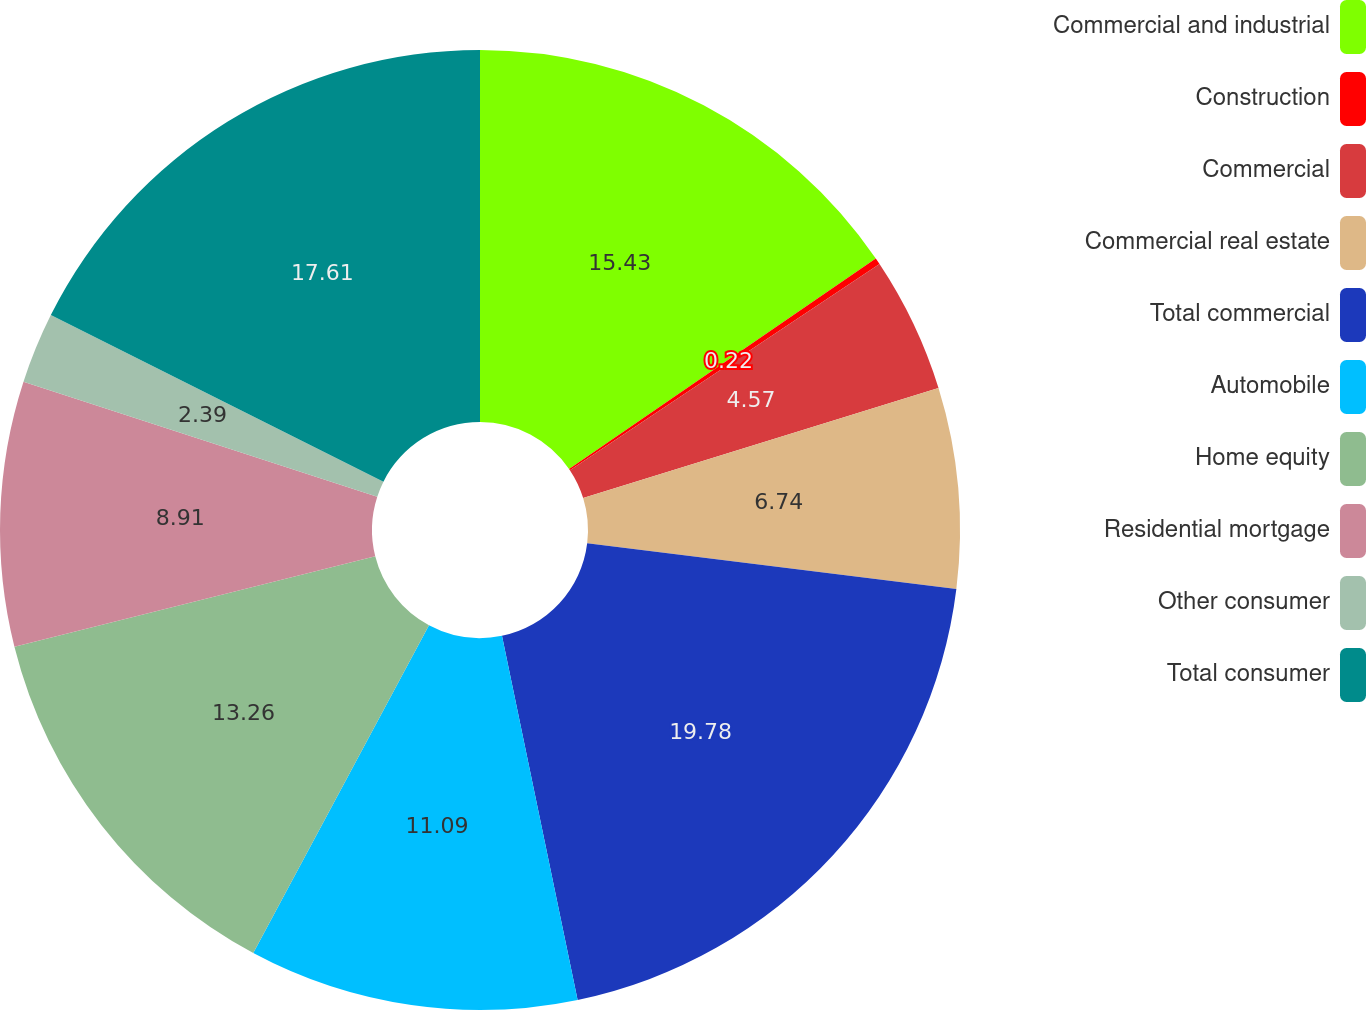Convert chart to OTSL. <chart><loc_0><loc_0><loc_500><loc_500><pie_chart><fcel>Commercial and industrial<fcel>Construction<fcel>Commercial<fcel>Commercial real estate<fcel>Total commercial<fcel>Automobile<fcel>Home equity<fcel>Residential mortgage<fcel>Other consumer<fcel>Total consumer<nl><fcel>15.43%<fcel>0.22%<fcel>4.57%<fcel>6.74%<fcel>19.78%<fcel>11.09%<fcel>13.26%<fcel>8.91%<fcel>2.39%<fcel>17.61%<nl></chart> 